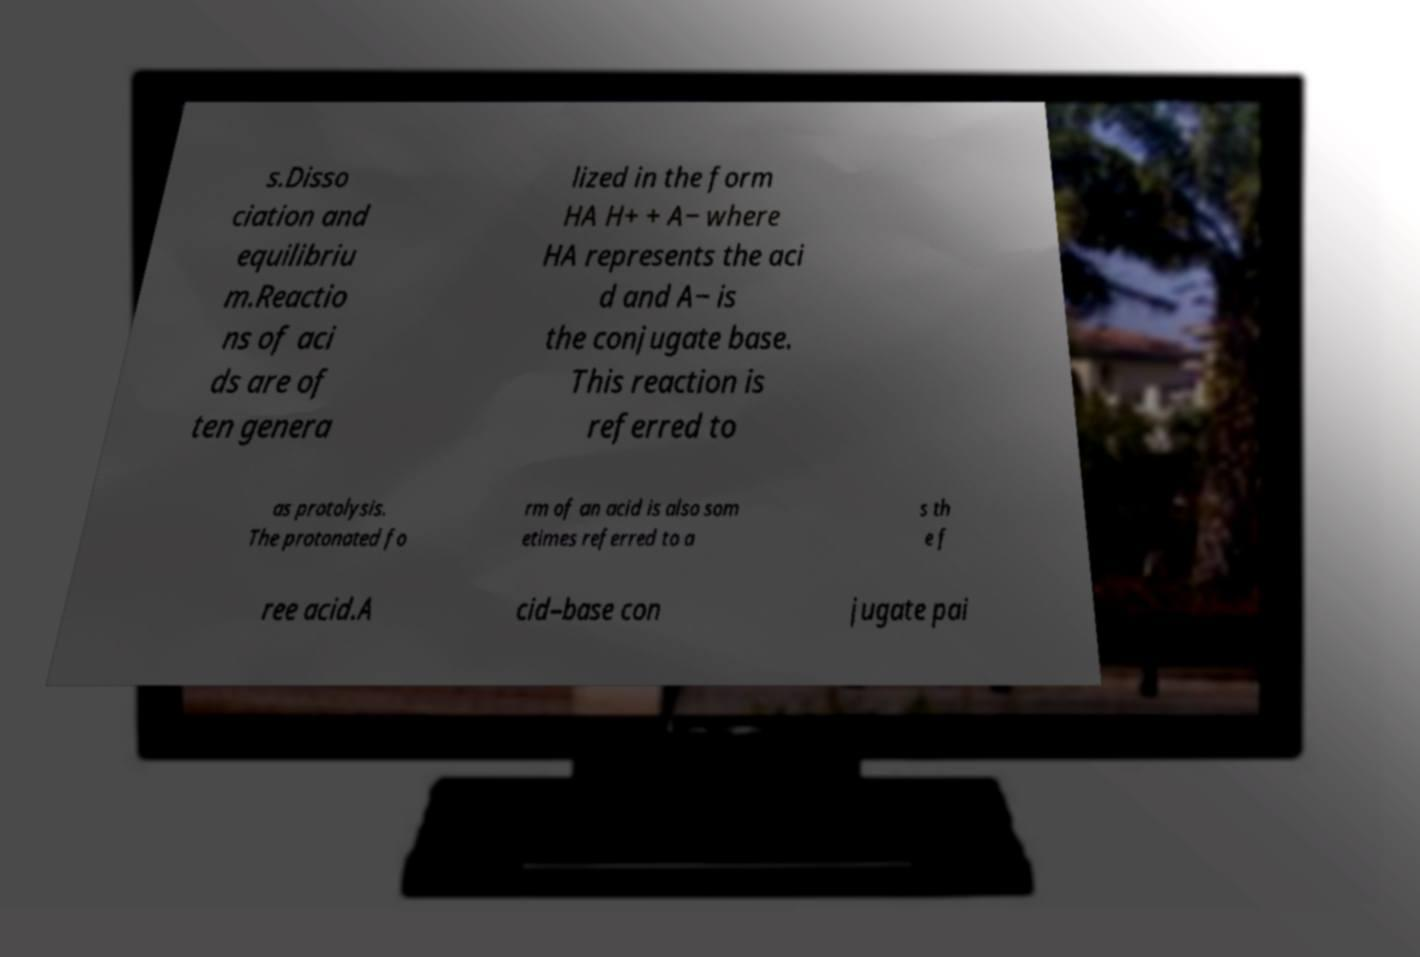I need the written content from this picture converted into text. Can you do that? s.Disso ciation and equilibriu m.Reactio ns of aci ds are of ten genera lized in the form HA H+ + A− where HA represents the aci d and A− is the conjugate base. This reaction is referred to as protolysis. The protonated fo rm of an acid is also som etimes referred to a s th e f ree acid.A cid–base con jugate pai 